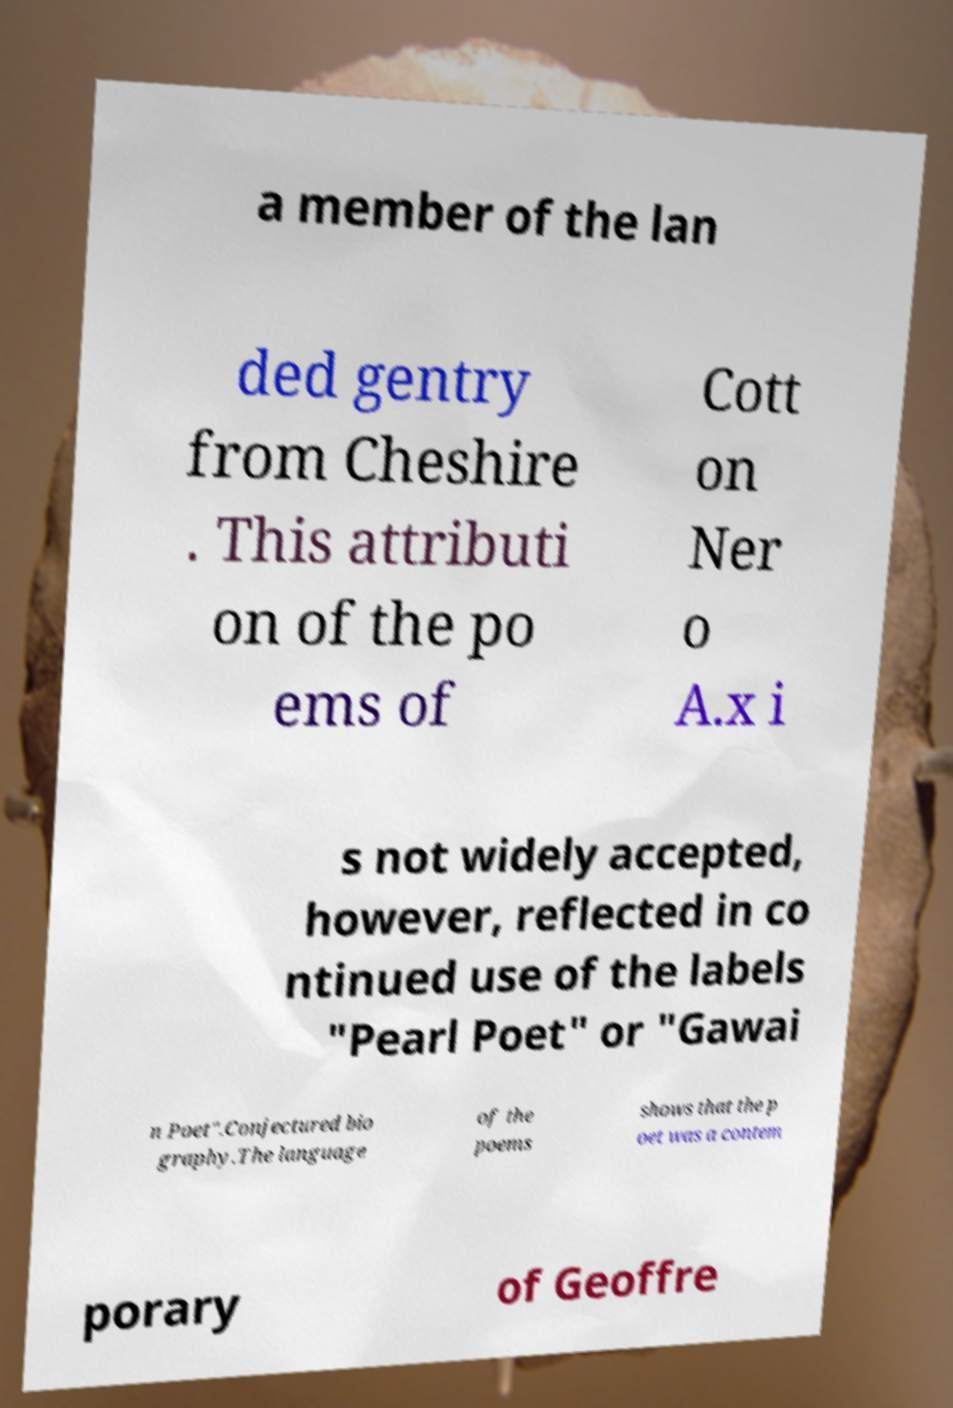There's text embedded in this image that I need extracted. Can you transcribe it verbatim? a member of the lan ded gentry from Cheshire . This attributi on of the po ems of Cott on Ner o A.x i s not widely accepted, however, reflected in co ntinued use of the labels "Pearl Poet" or "Gawai n Poet".Conjectured bio graphy.The language of the poems shows that the p oet was a contem porary of Geoffre 